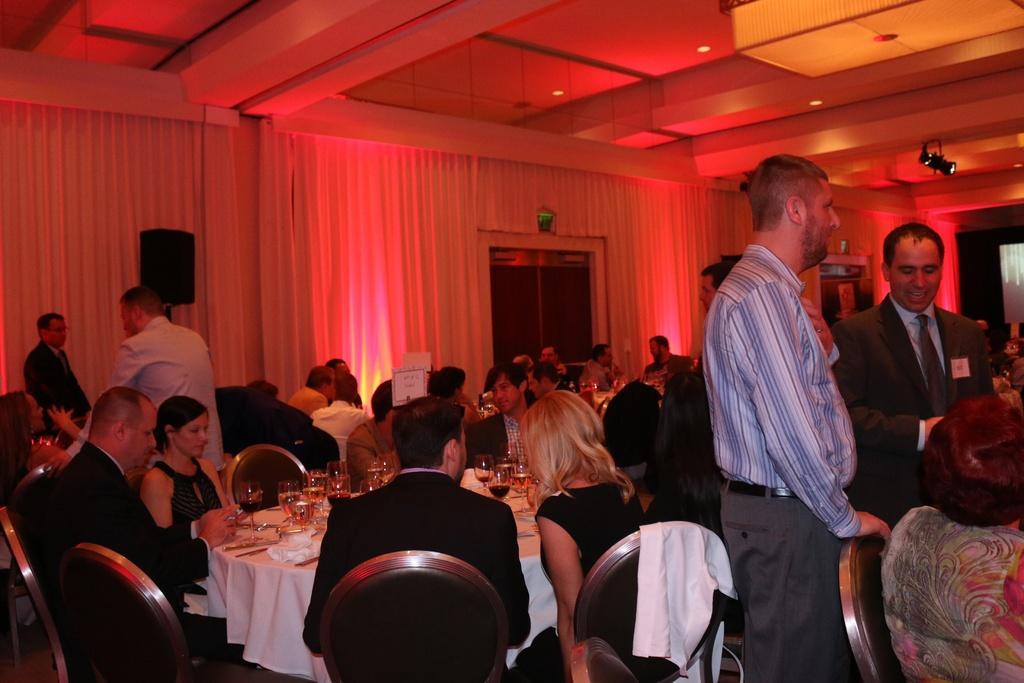Could you give a brief overview of what you see in this image? In this picture, There are some table which are in white color and there are some people sitting on the chairs around the tables and in the background there is a white color curtain and in the top there is a white color wall. 